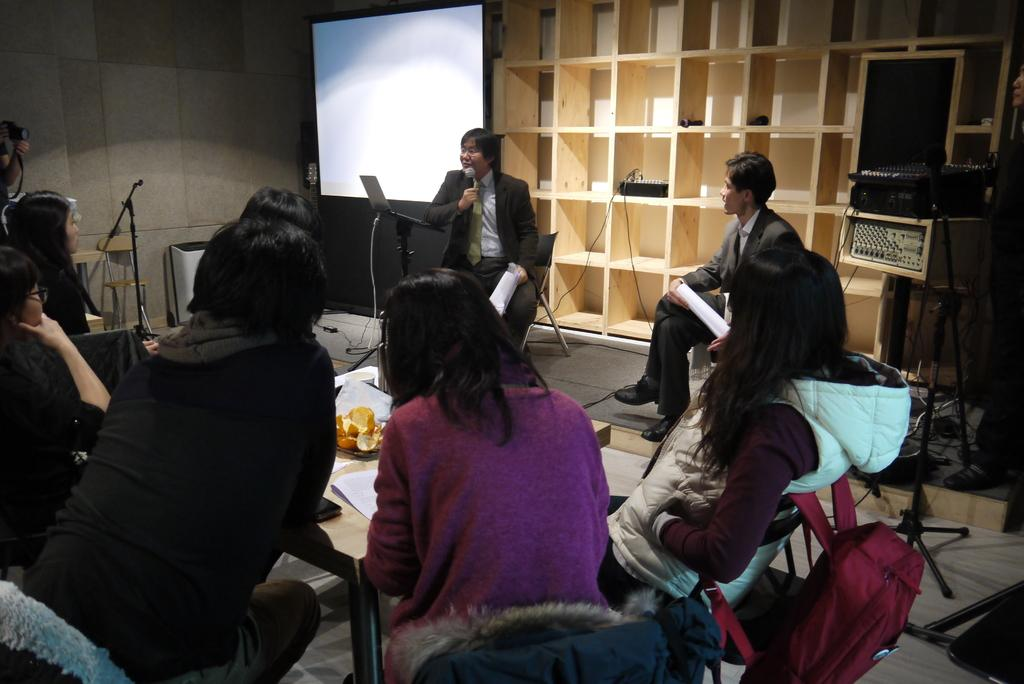What are the people in the image doing? There is a group of people sitting in the image. What can be seen on the table in the image? There are objects on the table in the image. What is visible in the background of the image? There is a shelf visible in the background of the image. Can you see the ocean in the image? No, the ocean is not present in the image. What type of beast is sitting with the group of people? There is no beast present in the image; it features a group of people sitting. 